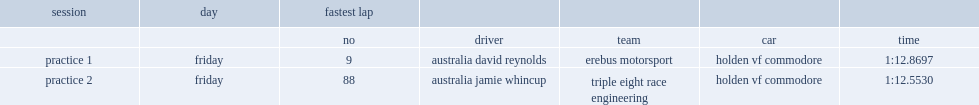What was the time of david reynolds in practice 1? 1:12.8697. 